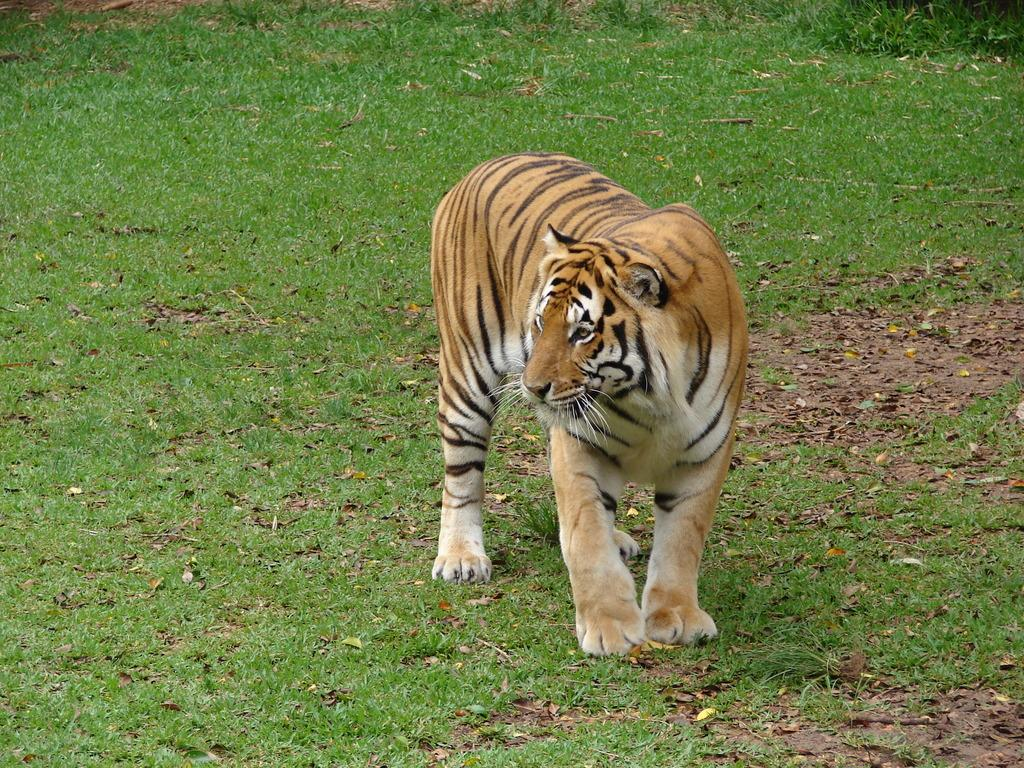What type of animal is in the image? There is a tiger in the image. What type of terrain is visible in the image? There is grass visible in the image. What else can be seen on the ground in the image? There are leaves on the ground in the image. What type of mint is growing near the tiger in the image? There is no mint visible in the image; only grass and leaves are present on the ground. 